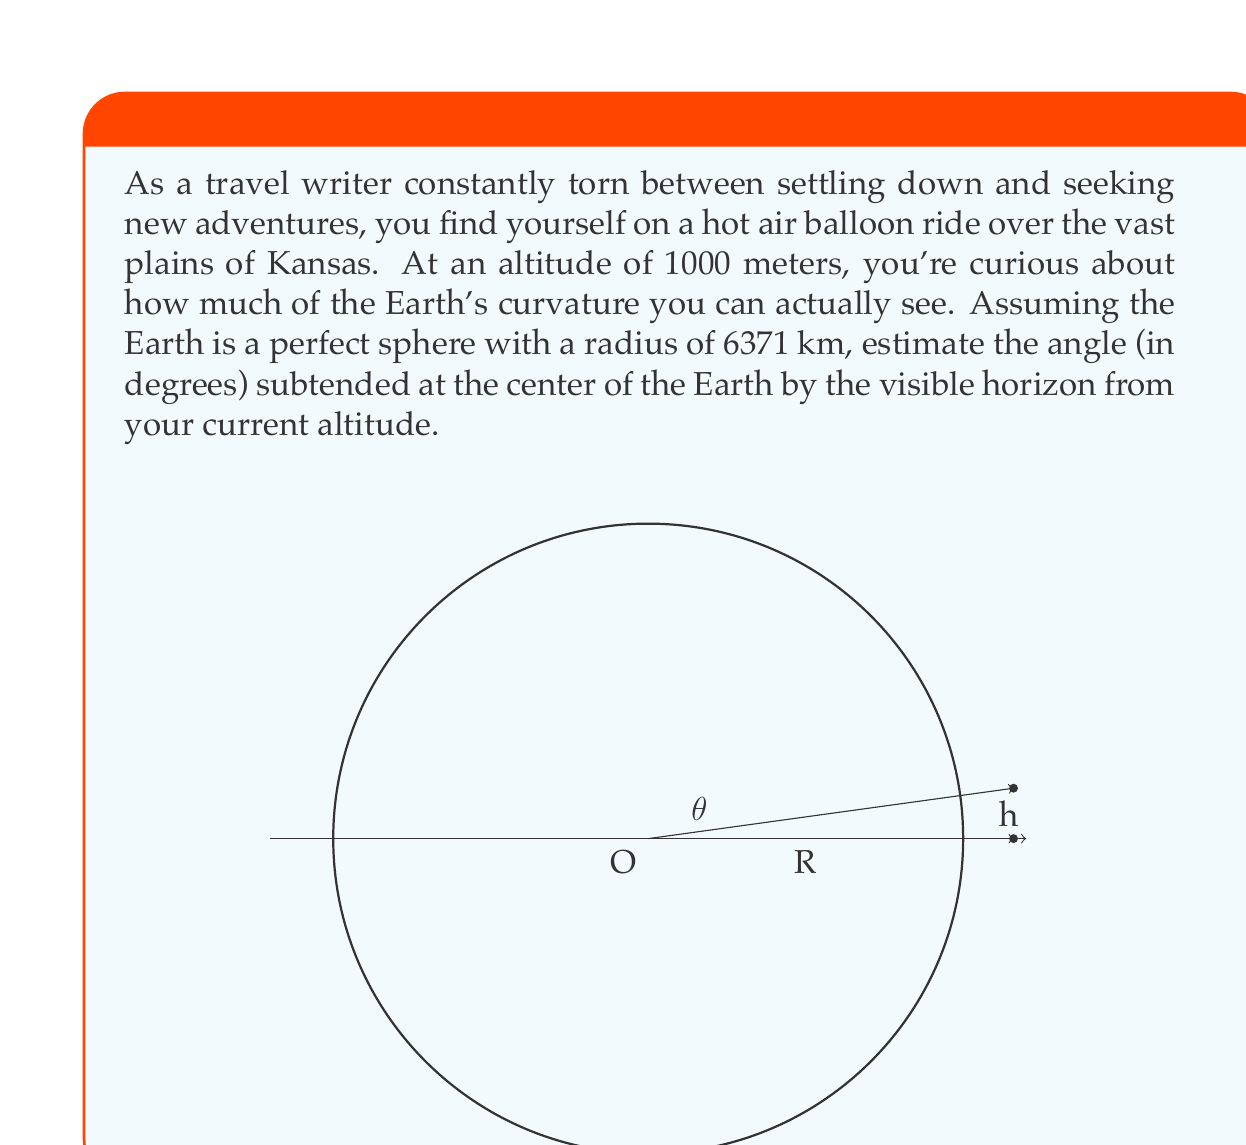Help me with this question. Let's approach this step-by-step:

1) First, we need to understand the geometry of the situation. We have a right-angled triangle formed by:
   - The center of the Earth (O)
   - The point where you are in the hot air balloon
   - The point on the horizon that's visible to you

2) In this triangle:
   - The hypotenuse is $R + h$, where $R$ is the Earth's radius and $h$ is your altitude
   - One side is $R$
   - The angle we're looking for is the one at the center of the Earth, let's call it $\theta$

3) We can use the cosine function to find this angle:

   $\cos(\theta) = \frac{R}{R+h}$

4) Therefore:

   $\theta = \arccos(\frac{R}{R+h})$

5) Now, let's plug in our values:
   $R = 6371000$ m (converting km to m)
   $h = 1000$ m

6) Calculating:

   $\theta = \arccos(\frac{6371000}{6371000 + 1000})$
   
   $= \arccos(\frac{6371000}{6372000})$
   
   $= \arccos(0.99984308)$

7) Using a calculator or computer:

   $\theta \approx 0.0320752$ radians

8) Converting to degrees:

   $\theta \approx 0.0320752 \times \frac{180}{\pi} \approx 1.8378$ degrees
Answer: The angle subtended at the center of the Earth by the visible horizon from an altitude of 1000 meters is approximately 1.84 degrees. 